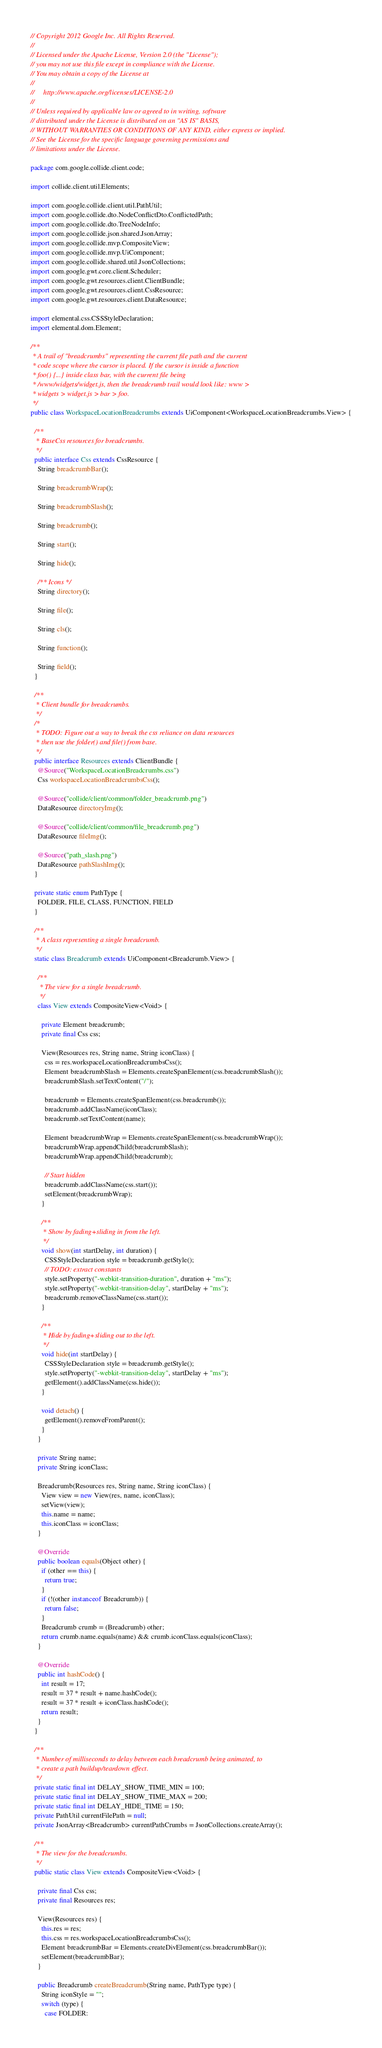<code> <loc_0><loc_0><loc_500><loc_500><_Java_>// Copyright 2012 Google Inc. All Rights Reserved.
//
// Licensed under the Apache License, Version 2.0 (the "License");
// you may not use this file except in compliance with the License.
// You may obtain a copy of the License at
//
//     http://www.apache.org/licenses/LICENSE-2.0
//
// Unless required by applicable law or agreed to in writing, software
// distributed under the License is distributed on an "AS IS" BASIS,
// WITHOUT WARRANTIES OR CONDITIONS OF ANY KIND, either express or implied.
// See the License for the specific language governing permissions and
// limitations under the License.

package com.google.collide.client.code;

import collide.client.util.Elements;

import com.google.collide.client.util.PathUtil;
import com.google.collide.dto.NodeConflictDto.ConflictedPath;
import com.google.collide.dto.TreeNodeInfo;
import com.google.collide.json.shared.JsonArray;
import com.google.collide.mvp.CompositeView;
import com.google.collide.mvp.UiComponent;
import com.google.collide.shared.util.JsonCollections;
import com.google.gwt.core.client.Scheduler;
import com.google.gwt.resources.client.ClientBundle;
import com.google.gwt.resources.client.CssResource;
import com.google.gwt.resources.client.DataResource;

import elemental.css.CSSStyleDeclaration;
import elemental.dom.Element;

/**
 * A trail of "breadcrumbs" representing the current file path and the current
 * code scope where the cursor is placed. If the cursor is inside a function
 * foo() {...} inside class bar, with the current file being
 * /www/widgets/widget.js, then the breadcrumb trail would look like: www >
 * widgets > widget.js > bar > foo.
 */
public class WorkspaceLocationBreadcrumbs extends UiComponent<WorkspaceLocationBreadcrumbs.View> {

  /**
   * BaseCss resources for breadcrumbs.
   */
  public interface Css extends CssResource {
    String breadcrumbBar();

    String breadcrumbWrap();

    String breadcrumbSlash();

    String breadcrumb();

    String start();

    String hide();

    /** Icons */
    String directory();

    String file();

    String cls();

    String function();

    String field();
  }

  /**
   * Client bundle for breadcrumbs.
   */
  /*
   * TODO: Figure out a way to break the css reliance on data resources
   * then use the folder() and file() from base.
   */
  public interface Resources extends ClientBundle {
    @Source("WorkspaceLocationBreadcrumbs.css")
    Css workspaceLocationBreadcrumbsCss();

    @Source("collide/client/common/folder_breadcrumb.png")
    DataResource directoryImg();

    @Source("collide/client/common/file_breadcrumb.png")
    DataResource fileImg();

    @Source("path_slash.png")
    DataResource pathSlashImg();
  }

  private static enum PathType {
    FOLDER, FILE, CLASS, FUNCTION, FIELD
  }

  /**
   * A class representing a single breadcrumb.
   */
  static class Breadcrumb extends UiComponent<Breadcrumb.View> {

    /**
     * The view for a single breadcrumb.
     */
    class View extends CompositeView<Void> {

      private Element breadcrumb;
      private final Css css;

      View(Resources res, String name, String iconClass) {
        css = res.workspaceLocationBreadcrumbsCss();
        Element breadcrumbSlash = Elements.createSpanElement(css.breadcrumbSlash());
        breadcrumbSlash.setTextContent("/");

        breadcrumb = Elements.createSpanElement(css.breadcrumb());
        breadcrumb.addClassName(iconClass);
        breadcrumb.setTextContent(name);

        Element breadcrumbWrap = Elements.createSpanElement(css.breadcrumbWrap());
        breadcrumbWrap.appendChild(breadcrumbSlash);
        breadcrumbWrap.appendChild(breadcrumb);

        // Start hidden
        breadcrumb.addClassName(css.start());
        setElement(breadcrumbWrap);
      }

      /**
       * Show by fading+sliding in from the left.
       */
      void show(int startDelay, int duration) {
        CSSStyleDeclaration style = breadcrumb.getStyle();
        // TODO: extract constants
        style.setProperty("-webkit-transition-duration", duration + "ms");
        style.setProperty("-webkit-transition-delay", startDelay + "ms");
        breadcrumb.removeClassName(css.start());
      }

      /**
       * Hide by fading+sliding out to the left.
       */
      void hide(int startDelay) {
        CSSStyleDeclaration style = breadcrumb.getStyle();
        style.setProperty("-webkit-transition-delay", startDelay + "ms");
        getElement().addClassName(css.hide());
      }

      void detach() {
        getElement().removeFromParent();
      }
    }

    private String name;
    private String iconClass;

    Breadcrumb(Resources res, String name, String iconClass) {
      View view = new View(res, name, iconClass);
      setView(view);
      this.name = name;
      this.iconClass = iconClass;
    }

    @Override
    public boolean equals(Object other) {
      if (other == this) {
        return true;
      }
      if (!(other instanceof Breadcrumb)) {
        return false;
      }
      Breadcrumb crumb = (Breadcrumb) other;
      return crumb.name.equals(name) && crumb.iconClass.equals(iconClass);
    }

    @Override
    public int hashCode() {
      int result = 17;
      result = 37 * result + name.hashCode();
      result = 37 * result + iconClass.hashCode();
      return result;
    }
  }

  /**
   * Number of milliseconds to delay between each breadcrumb being animated, to
   * create a path buildup/teardown effect.
   */
  private static final int DELAY_SHOW_TIME_MIN = 100;
  private static final int DELAY_SHOW_TIME_MAX = 200;
  private static final int DELAY_HIDE_TIME = 150;
  private PathUtil currentFilePath = null;
  private JsonArray<Breadcrumb> currentPathCrumbs = JsonCollections.createArray();

  /**
   * The view for the breadcrumbs.
   */
  public static class View extends CompositeView<Void> {

    private final Css css;
    private final Resources res;

    View(Resources res) {
      this.res = res;
      this.css = res.workspaceLocationBreadcrumbsCss();
      Element breadcrumbBar = Elements.createDivElement(css.breadcrumbBar());
      setElement(breadcrumbBar);
    }

    public Breadcrumb createBreadcrumb(String name, PathType type) {
      String iconStyle = "";
      switch (type) {
        case FOLDER:</code> 